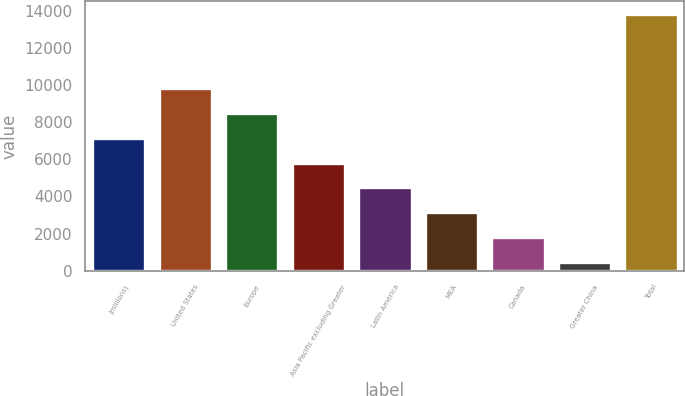Convert chart. <chart><loc_0><loc_0><loc_500><loc_500><bar_chart><fcel>(millions)<fcel>United States<fcel>Europe<fcel>Asia Pacific excluding Greater<fcel>Latin America<fcel>MEA<fcel>Canada<fcel>Greater China<fcel>Total<nl><fcel>7161<fcel>9831.92<fcel>8496.46<fcel>5825.54<fcel>4490.08<fcel>3154.62<fcel>1819.16<fcel>483.7<fcel>13838.3<nl></chart> 